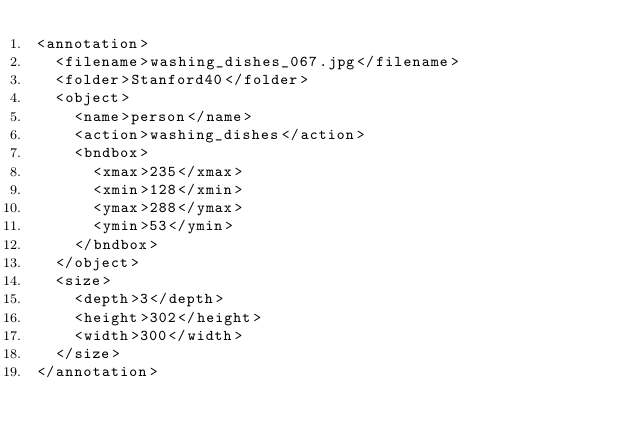<code> <loc_0><loc_0><loc_500><loc_500><_XML_><annotation>
  <filename>washing_dishes_067.jpg</filename>
  <folder>Stanford40</folder>
  <object>
    <name>person</name>
    <action>washing_dishes</action>
    <bndbox>
      <xmax>235</xmax>
      <xmin>128</xmin>
      <ymax>288</ymax>
      <ymin>53</ymin>
    </bndbox>
  </object>
  <size>
    <depth>3</depth>
    <height>302</height>
    <width>300</width>
  </size>
</annotation>
</code> 